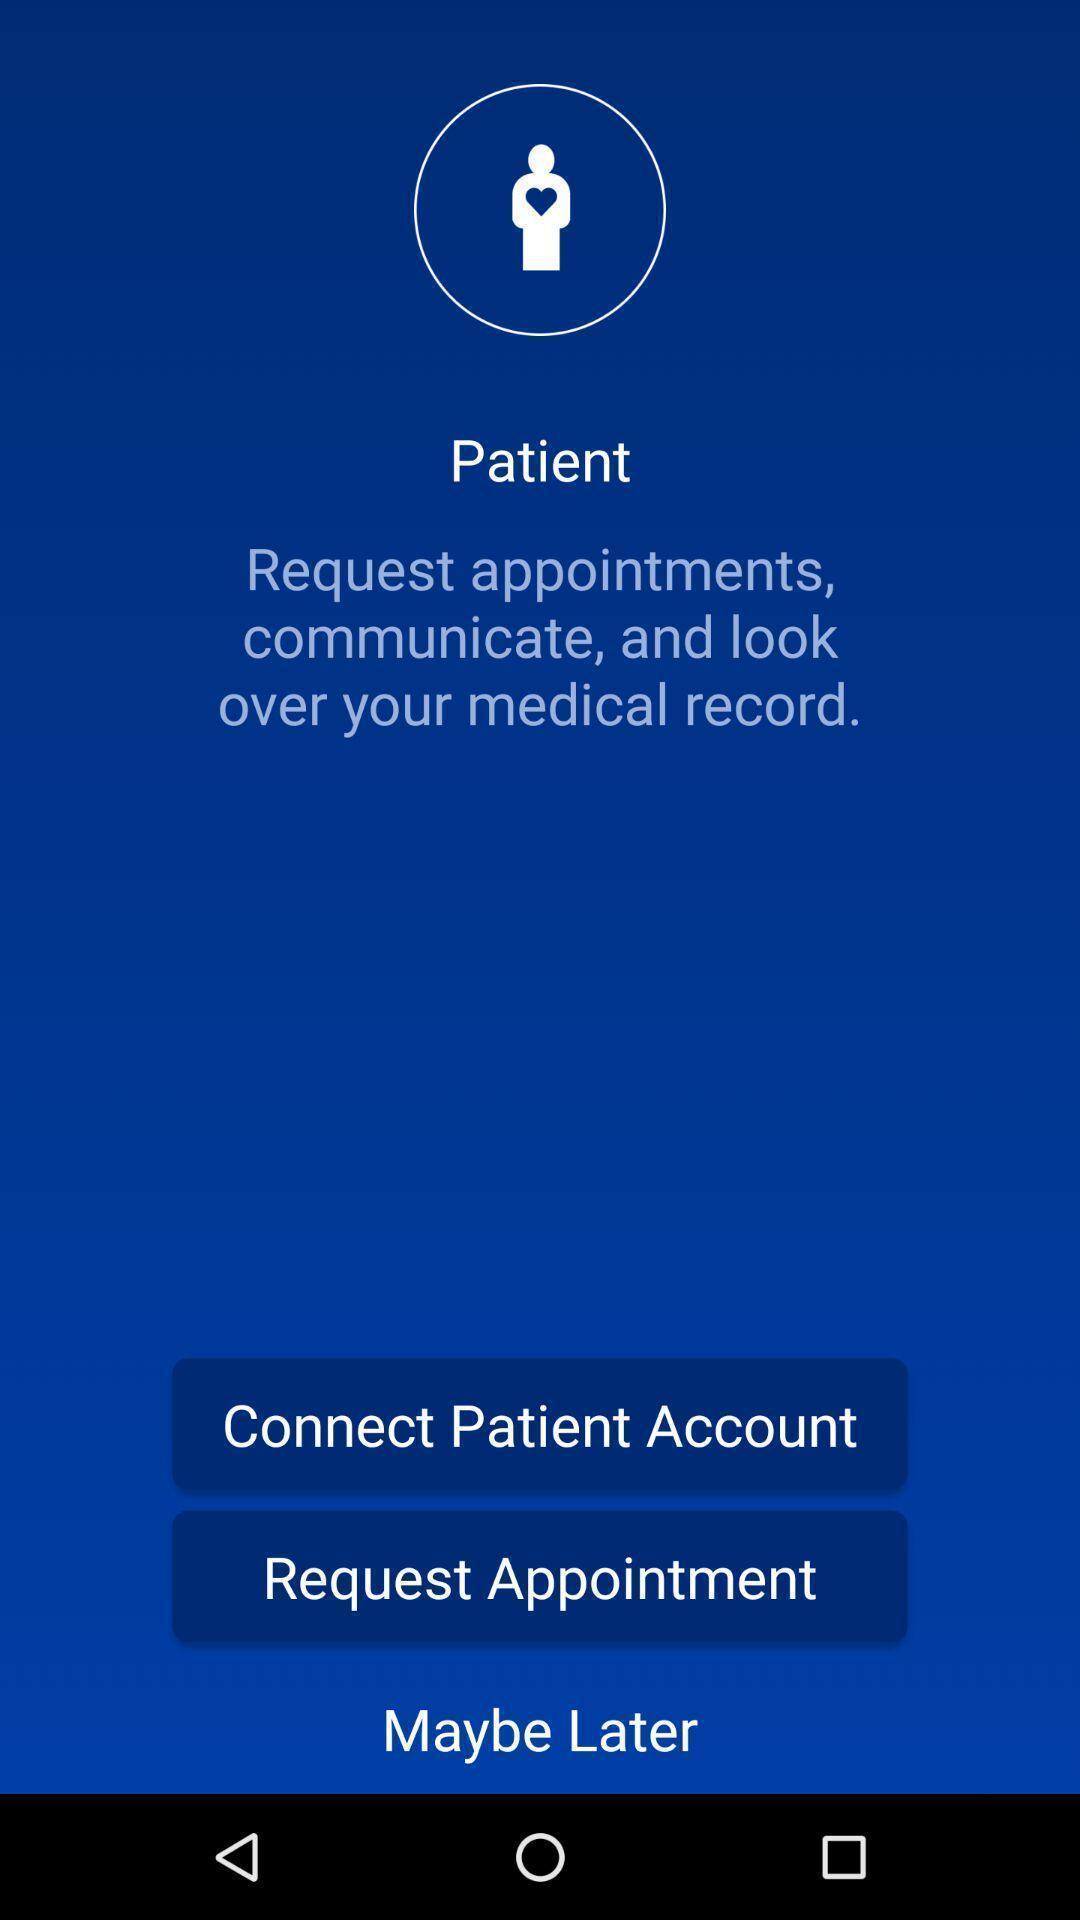Describe the key features of this screenshot. Screen shows multiple options in a health application. 